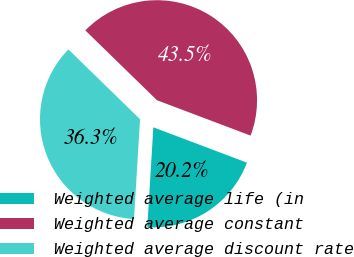<chart> <loc_0><loc_0><loc_500><loc_500><pie_chart><fcel>Weighted average life (in<fcel>Weighted average constant<fcel>Weighted average discount rate<nl><fcel>20.22%<fcel>43.45%<fcel>36.33%<nl></chart> 